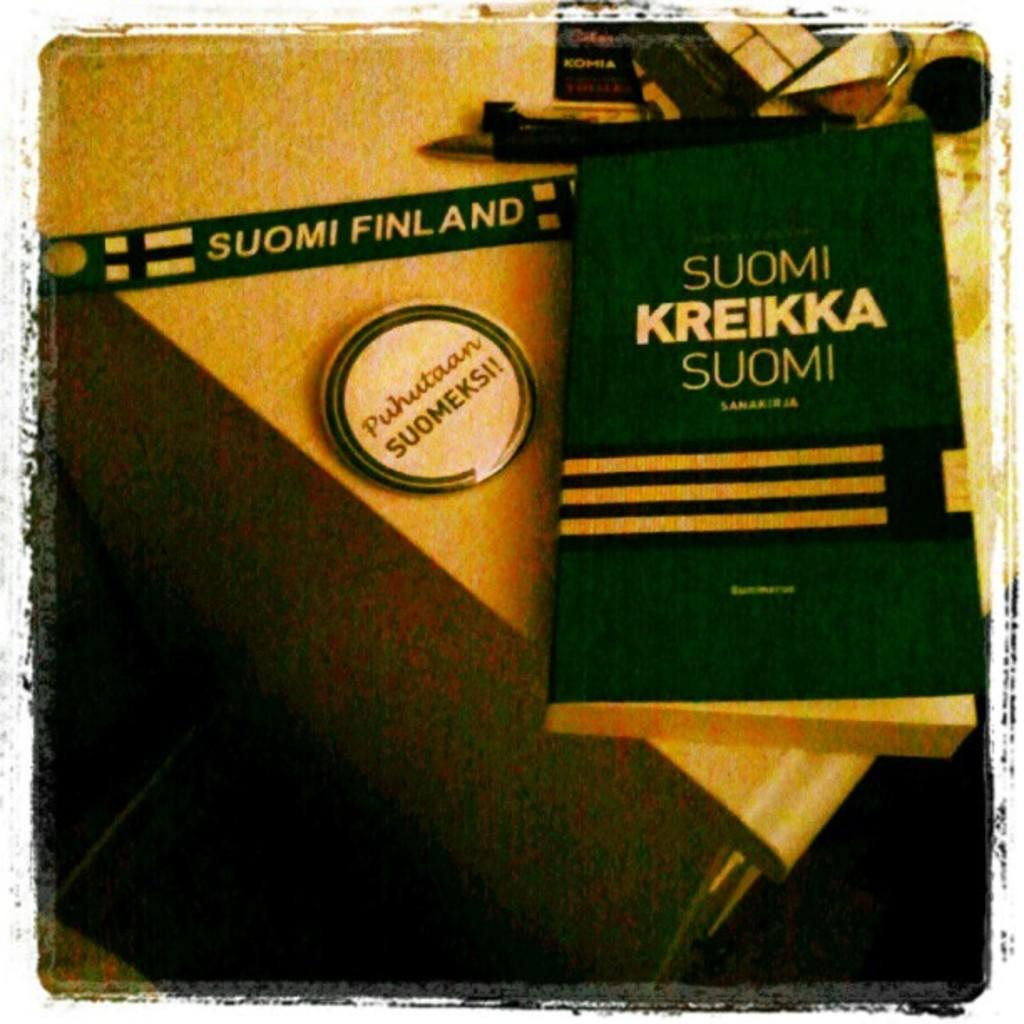<image>
Render a clear and concise summary of the photo. A book, pin and lanyard for Suomi on a desk. 